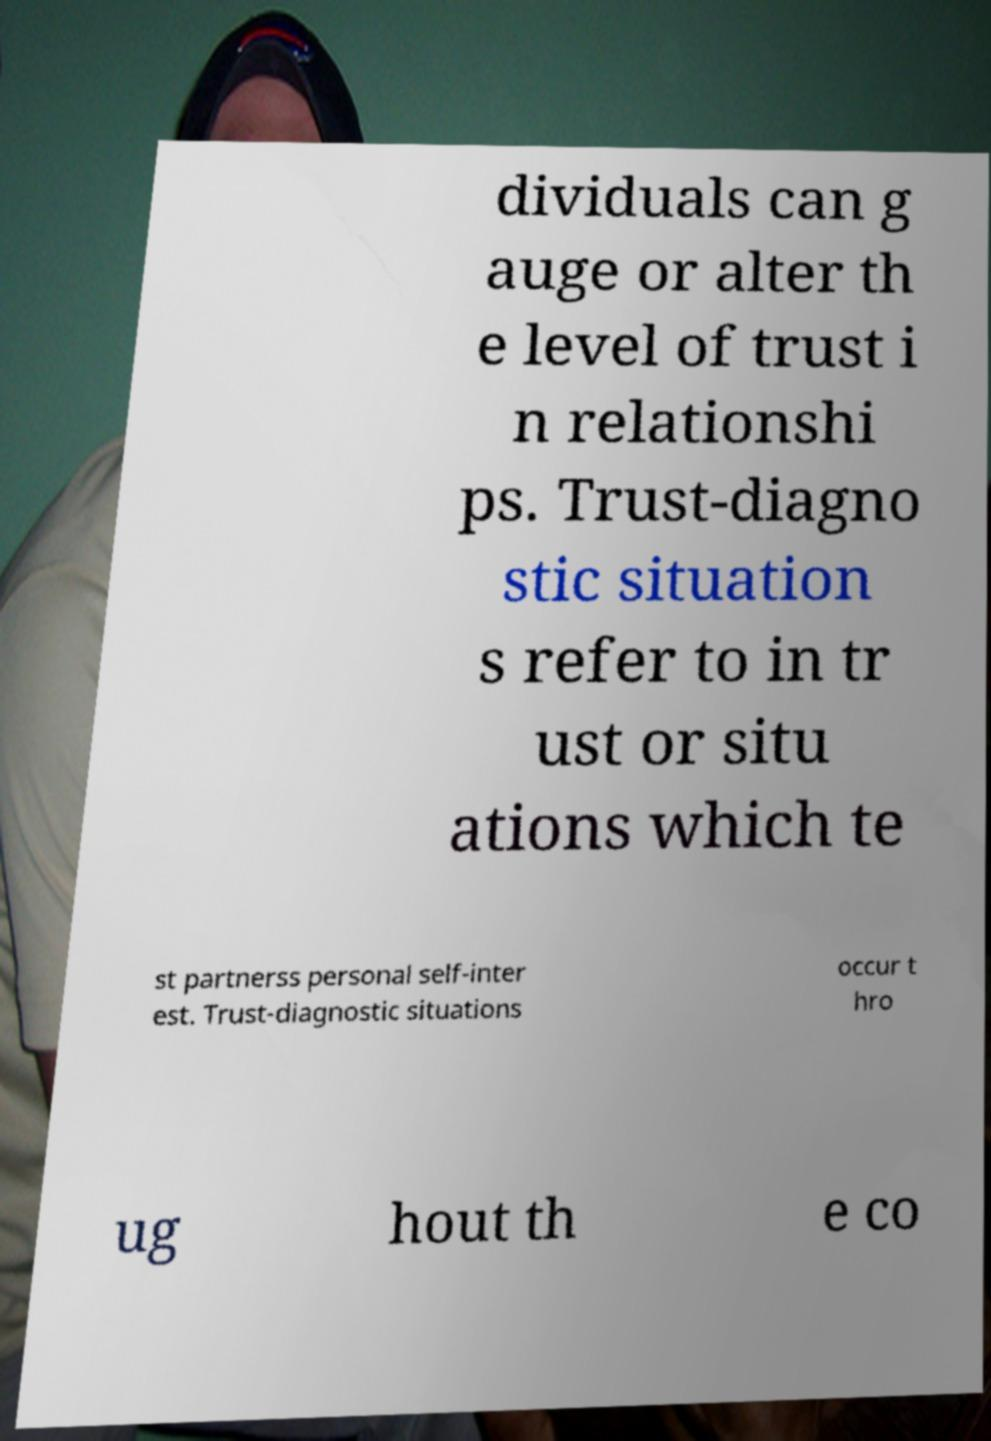What messages or text are displayed in this image? I need them in a readable, typed format. dividuals can g auge or alter th e level of trust i n relationshi ps. Trust-diagno stic situation s refer to in tr ust or situ ations which te st partnerss personal self-inter est. Trust-diagnostic situations occur t hro ug hout th e co 